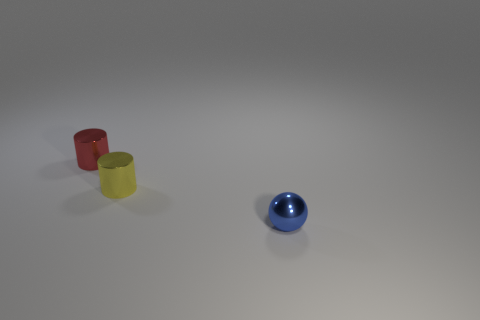Add 2 tiny green metallic balls. How many objects exist? 5 Subtract all cylinders. How many objects are left? 1 Subtract all cylinders. Subtract all cyan blocks. How many objects are left? 1 Add 3 blue metallic balls. How many blue metallic balls are left? 4 Add 3 big green rubber spheres. How many big green rubber spheres exist? 3 Subtract 0 green balls. How many objects are left? 3 